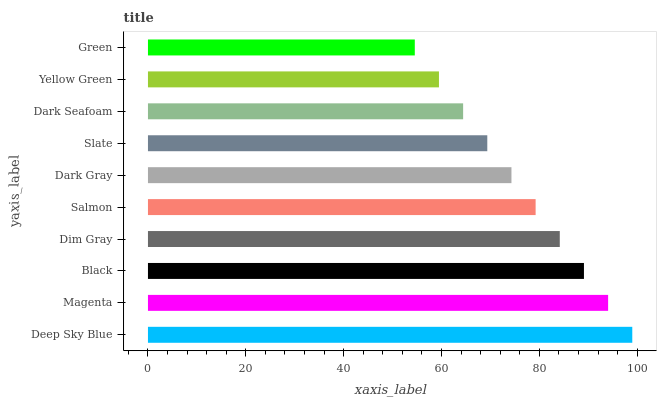Is Green the minimum?
Answer yes or no. Yes. Is Deep Sky Blue the maximum?
Answer yes or no. Yes. Is Magenta the minimum?
Answer yes or no. No. Is Magenta the maximum?
Answer yes or no. No. Is Deep Sky Blue greater than Magenta?
Answer yes or no. Yes. Is Magenta less than Deep Sky Blue?
Answer yes or no. Yes. Is Magenta greater than Deep Sky Blue?
Answer yes or no. No. Is Deep Sky Blue less than Magenta?
Answer yes or no. No. Is Salmon the high median?
Answer yes or no. Yes. Is Dark Gray the low median?
Answer yes or no. Yes. Is Black the high median?
Answer yes or no. No. Is Slate the low median?
Answer yes or no. No. 